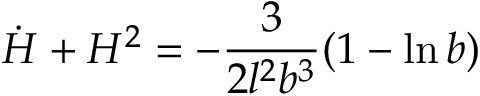<formula> <loc_0><loc_0><loc_500><loc_500>\dot { H } + H ^ { 2 } = - \frac { 3 } { 2 l ^ { 2 } b ^ { 3 } } ( 1 - \ln b )</formula> 